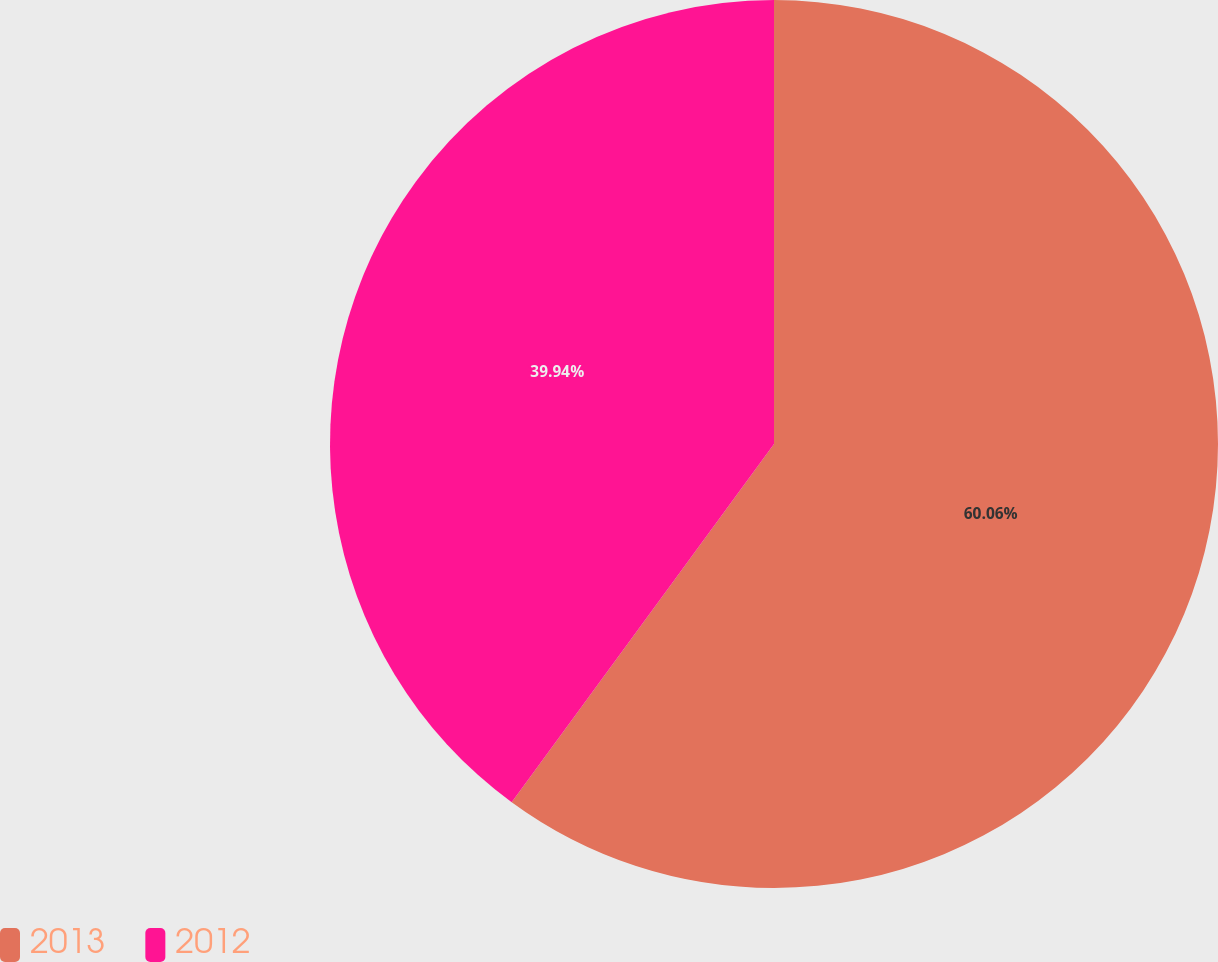Convert chart. <chart><loc_0><loc_0><loc_500><loc_500><pie_chart><fcel>2013<fcel>2012<nl><fcel>60.06%<fcel>39.94%<nl></chart> 